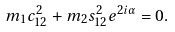Convert formula to latex. <formula><loc_0><loc_0><loc_500><loc_500>m _ { 1 } c _ { 1 2 } ^ { 2 } + m _ { 2 } s _ { 1 2 } ^ { 2 } e ^ { 2 i \alpha } = 0 .</formula> 